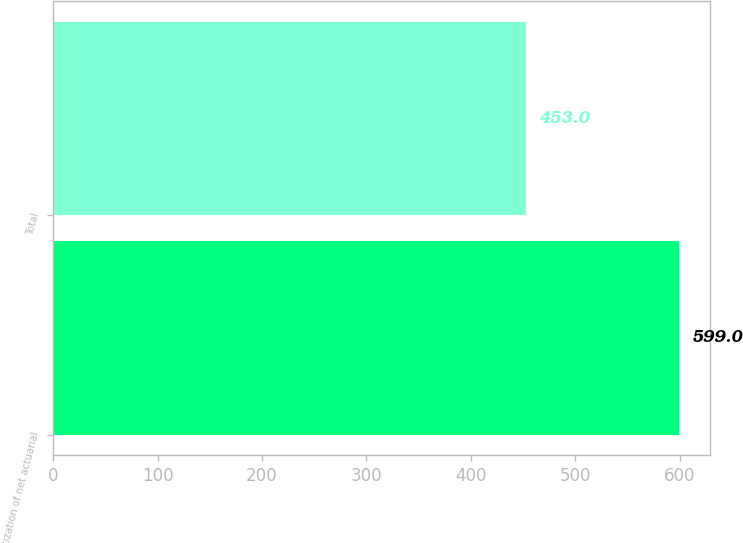Convert chart to OTSL. <chart><loc_0><loc_0><loc_500><loc_500><bar_chart><fcel>Amortization of net actuarial<fcel>Total<nl><fcel>599<fcel>453<nl></chart> 